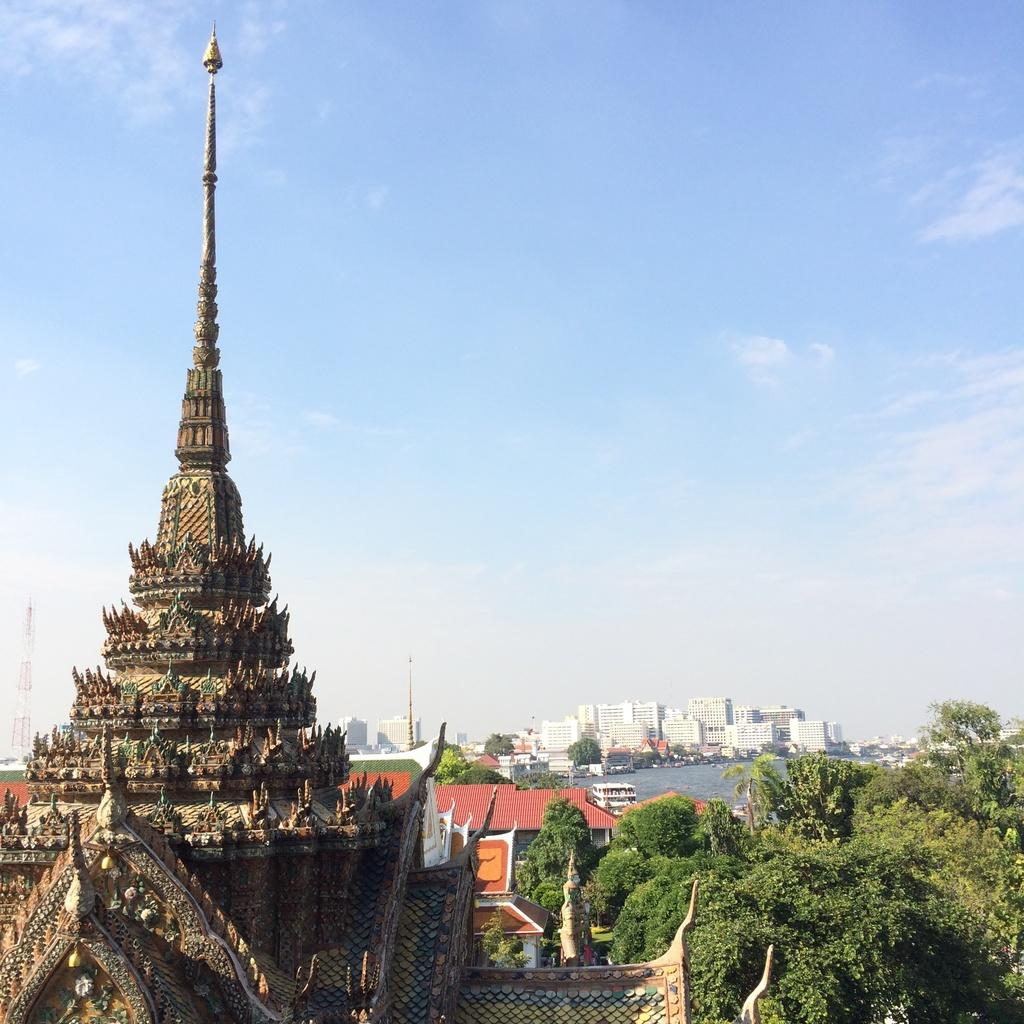What type of structures can be seen in the image? There are buildings in the image. What other natural elements are present in the image? There are trees and water visible in the image. What can be seen in the background of the image? There are towers in the background of the image. What is visible in the sky in the image? There are clouds in the sky. What type of musical instrument is being played in the image? There is no musical instrument present in the image. What type of stream can be seen in the image? There is no stream visible in the image; only water is mentioned. 